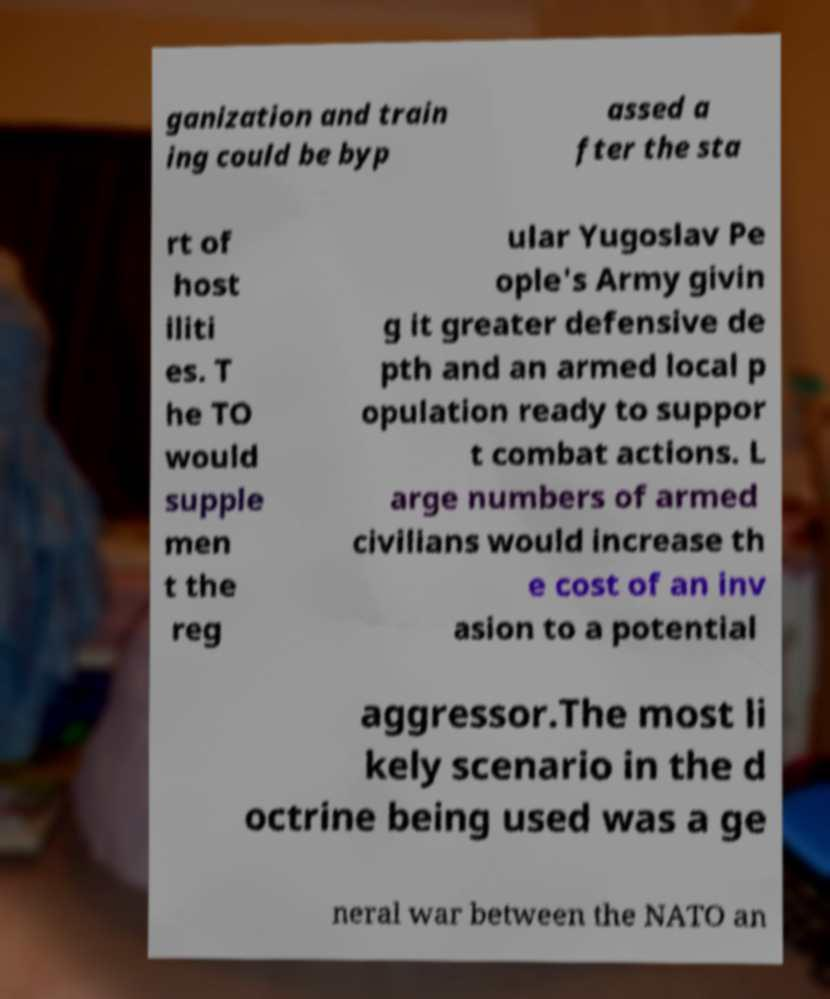What messages or text are displayed in this image? I need them in a readable, typed format. ganization and train ing could be byp assed a fter the sta rt of host iliti es. T he TO would supple men t the reg ular Yugoslav Pe ople's Army givin g it greater defensive de pth and an armed local p opulation ready to suppor t combat actions. L arge numbers of armed civilians would increase th e cost of an inv asion to a potential aggressor.The most li kely scenario in the d octrine being used was a ge neral war between the NATO an 